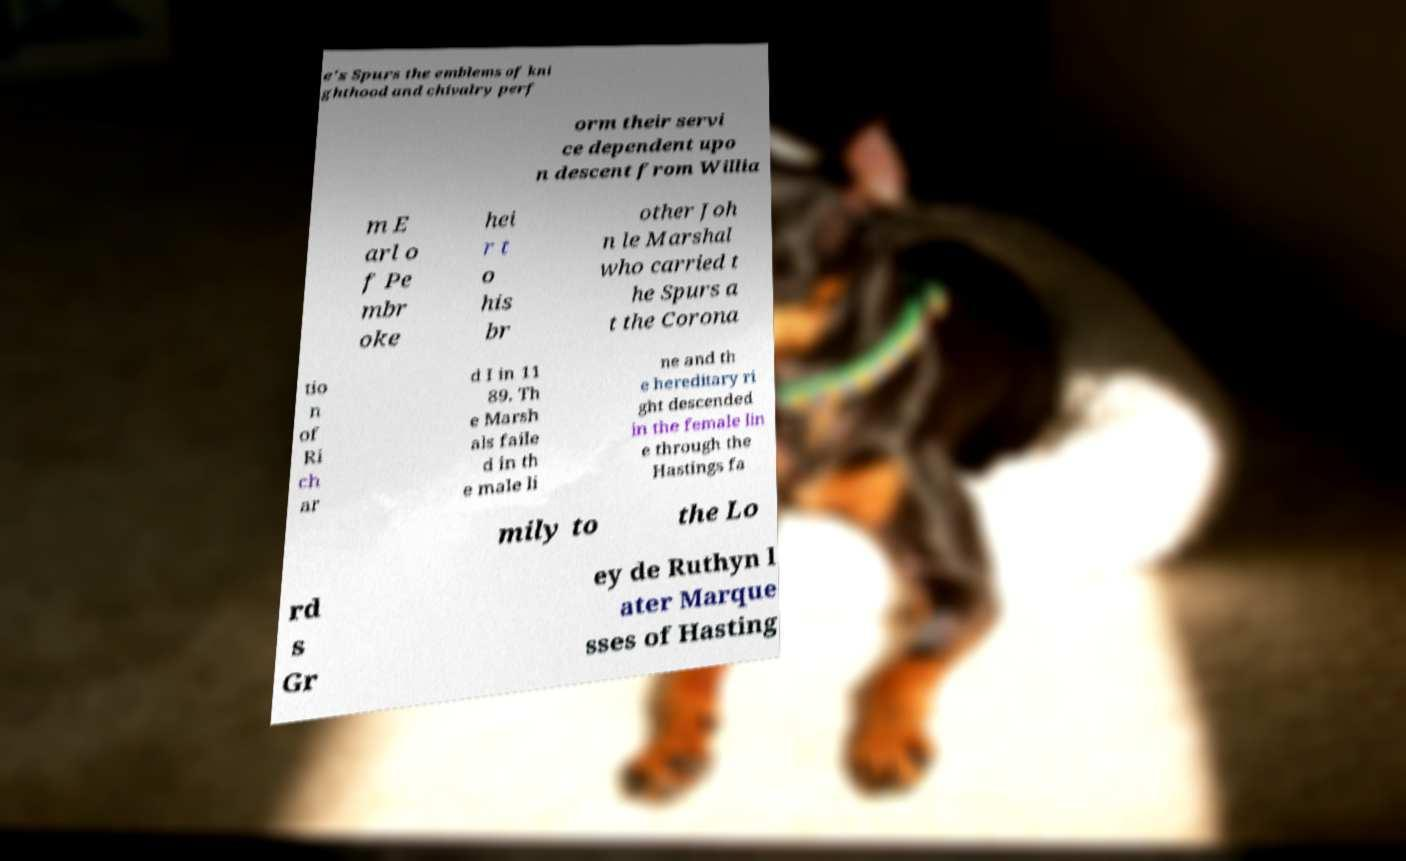Can you read and provide the text displayed in the image?This photo seems to have some interesting text. Can you extract and type it out for me? e's Spurs the emblems of kni ghthood and chivalry perf orm their servi ce dependent upo n descent from Willia m E arl o f Pe mbr oke hei r t o his br other Joh n le Marshal who carried t he Spurs a t the Corona tio n of Ri ch ar d I in 11 89. Th e Marsh als faile d in th e male li ne and th e hereditary ri ght descended in the female lin e through the Hastings fa mily to the Lo rd s Gr ey de Ruthyn l ater Marque sses of Hasting 